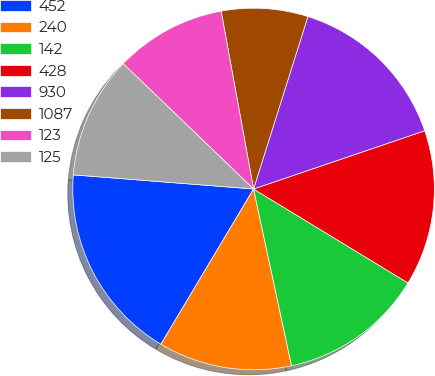Convert chart. <chart><loc_0><loc_0><loc_500><loc_500><pie_chart><fcel>452<fcel>240<fcel>142<fcel>428<fcel>930<fcel>1087<fcel>123<fcel>125<nl><fcel>17.68%<fcel>11.93%<fcel>12.93%<fcel>13.92%<fcel>14.92%<fcel>7.73%<fcel>9.94%<fcel>10.94%<nl></chart> 